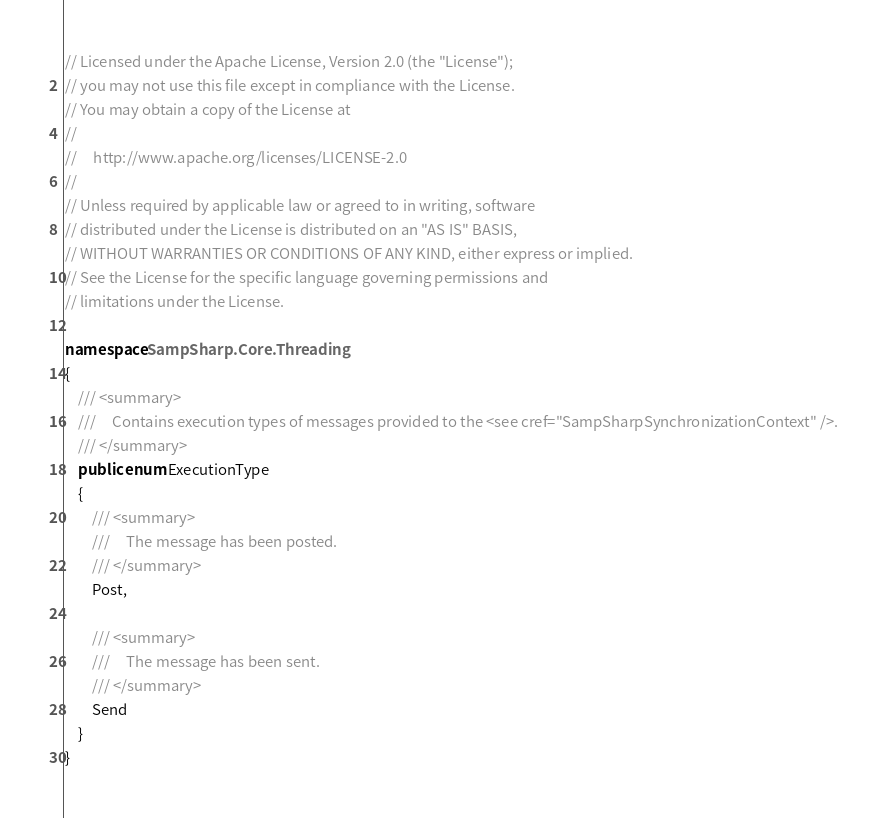Convert code to text. <code><loc_0><loc_0><loc_500><loc_500><_C#_>// Licensed under the Apache License, Version 2.0 (the "License");
// you may not use this file except in compliance with the License.
// You may obtain a copy of the License at
// 
//     http://www.apache.org/licenses/LICENSE-2.0
// 
// Unless required by applicable law or agreed to in writing, software
// distributed under the License is distributed on an "AS IS" BASIS,
// WITHOUT WARRANTIES OR CONDITIONS OF ANY KIND, either express or implied.
// See the License for the specific language governing permissions and
// limitations under the License.

namespace SampSharp.Core.Threading
{
    /// <summary>
    ///     Contains execution types of messages provided to the <see cref="SampSharpSynchronizationContext" />.
    /// </summary>
    public enum ExecutionType
    {
        /// <summary>
        ///     The message has been posted.
        /// </summary>
        Post,

        /// <summary>
        ///     The message has been sent.
        /// </summary>
        Send
    }
}</code> 